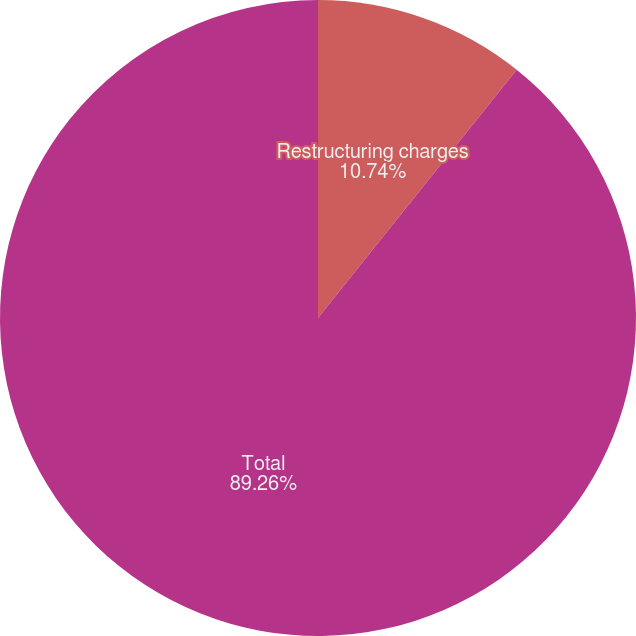Convert chart. <chart><loc_0><loc_0><loc_500><loc_500><pie_chart><fcel>Restructuring charges<fcel>Total<nl><fcel>10.74%<fcel>89.26%<nl></chart> 